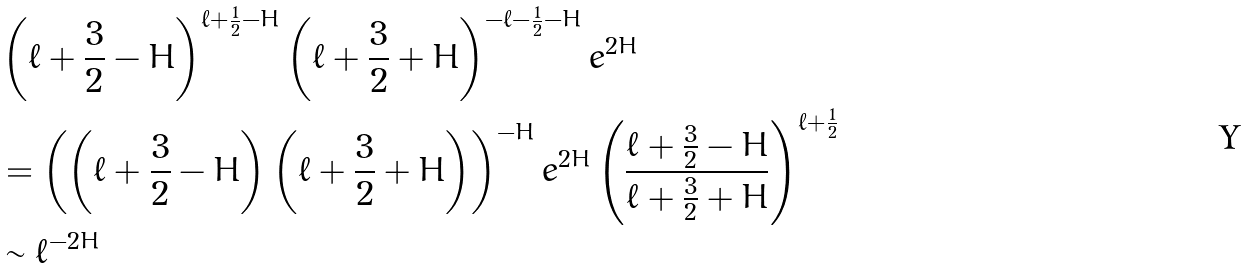<formula> <loc_0><loc_0><loc_500><loc_500>& \left ( \ell + \frac { 3 } { 2 } - H \right ) ^ { \ell + \frac { 1 } { 2 } - H } \left ( \ell + \frac { 3 } { 2 } + H \right ) ^ { - \ell - \frac { 1 } { 2 } - H } e ^ { 2 H } \\ & = \left ( \left ( \ell + \frac { 3 } { 2 } - H \right ) \left ( \ell + \frac { 3 } { 2 } + H \right ) \right ) ^ { - H } e ^ { 2 H } \left ( \frac { \ell + \frac { 3 } { 2 } - H } { \ell + \frac { 3 } { 2 } + H } \right ) ^ { \ell + \frac { 1 } { 2 } } \\ & \sim \ell ^ { - 2 H }</formula> 